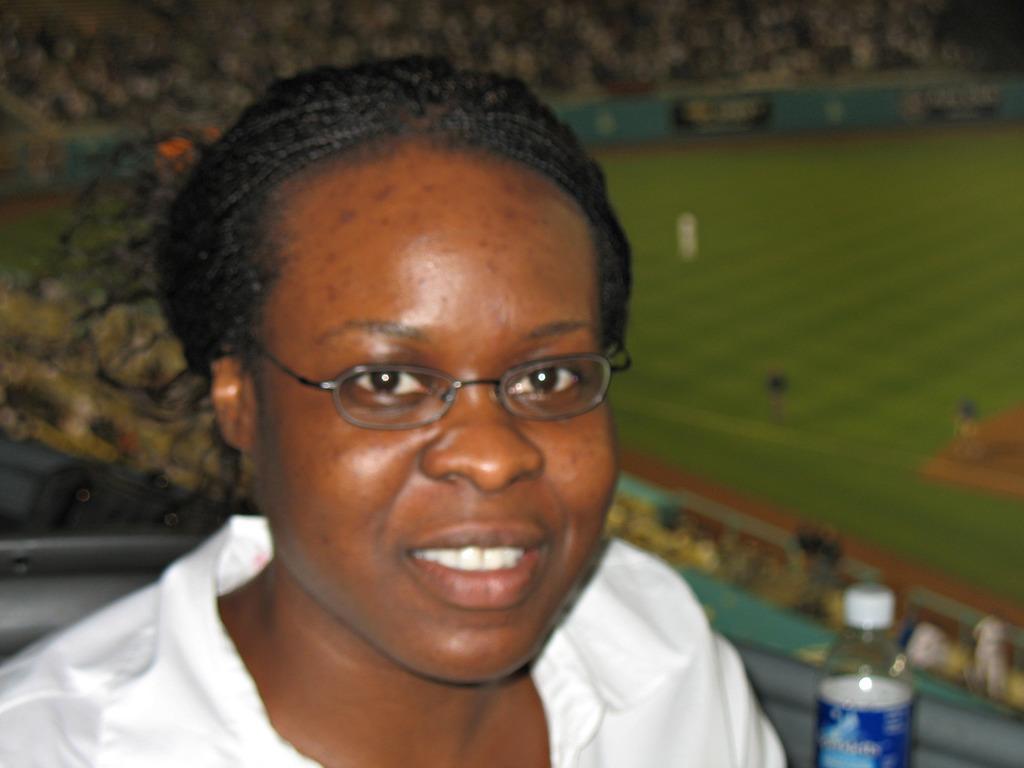Can you describe this image briefly? As we can see in the image, there is a woman and a bottle and the background is blurry. 